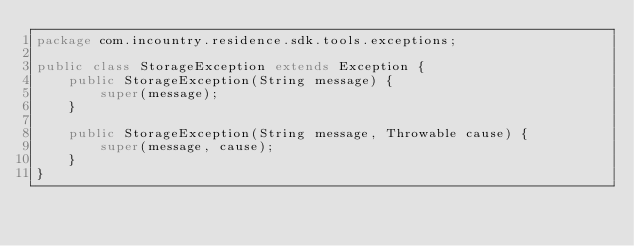<code> <loc_0><loc_0><loc_500><loc_500><_Java_>package com.incountry.residence.sdk.tools.exceptions;

public class StorageException extends Exception {
    public StorageException(String message) {
        super(message);
    }

    public StorageException(String message, Throwable cause) {
        super(message, cause);
    }
}</code> 